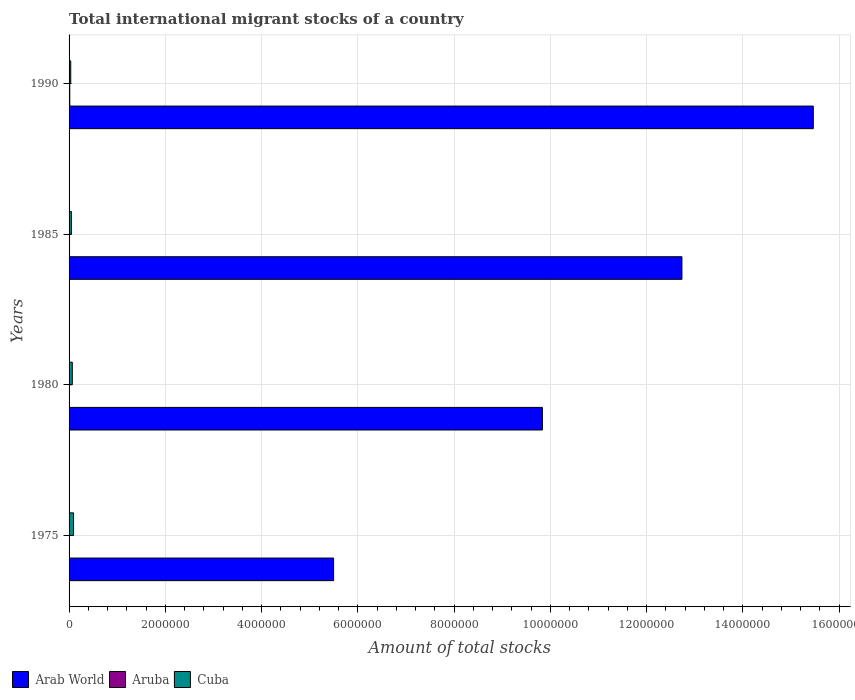How many different coloured bars are there?
Your answer should be compact. 3. How many groups of bars are there?
Your answer should be compact. 4. Are the number of bars on each tick of the Y-axis equal?
Keep it short and to the point. Yes. How many bars are there on the 3rd tick from the top?
Give a very brief answer. 3. How many bars are there on the 3rd tick from the bottom?
Your answer should be compact. 3. What is the amount of total stocks in in Cuba in 1990?
Offer a terse response. 3.46e+04. Across all years, what is the maximum amount of total stocks in in Aruba?
Offer a terse response. 1.44e+04. Across all years, what is the minimum amount of total stocks in in Arab World?
Your response must be concise. 5.50e+06. In which year was the amount of total stocks in in Aruba maximum?
Make the answer very short. 1990. In which year was the amount of total stocks in in Arab World minimum?
Your answer should be compact. 1975. What is the total amount of total stocks in in Arab World in the graph?
Your answer should be very brief. 4.35e+07. What is the difference between the amount of total stocks in in Cuba in 1975 and that in 1990?
Make the answer very short. 5.88e+04. What is the difference between the amount of total stocks in in Cuba in 1990 and the amount of total stocks in in Arab World in 1985?
Offer a terse response. -1.27e+07. What is the average amount of total stocks in in Arab World per year?
Give a very brief answer. 1.09e+07. In the year 1980, what is the difference between the amount of total stocks in in Cuba and amount of total stocks in in Arab World?
Offer a very short reply. -9.77e+06. What is the ratio of the amount of total stocks in in Aruba in 1975 to that in 1985?
Make the answer very short. 0.74. Is the amount of total stocks in in Arab World in 1985 less than that in 1990?
Your answer should be very brief. Yes. What is the difference between the highest and the second highest amount of total stocks in in Cuba?
Ensure brevity in your answer.  2.63e+04. What is the difference between the highest and the lowest amount of total stocks in in Cuba?
Provide a short and direct response. 5.88e+04. Is the sum of the amount of total stocks in in Cuba in 1975 and 1985 greater than the maximum amount of total stocks in in Arab World across all years?
Make the answer very short. No. What does the 3rd bar from the top in 1975 represents?
Keep it short and to the point. Arab World. What does the 1st bar from the bottom in 1990 represents?
Offer a terse response. Arab World. Is it the case that in every year, the sum of the amount of total stocks in in Cuba and amount of total stocks in in Arab World is greater than the amount of total stocks in in Aruba?
Keep it short and to the point. Yes. How many bars are there?
Provide a short and direct response. 12. Are all the bars in the graph horizontal?
Ensure brevity in your answer.  Yes. What is the difference between two consecutive major ticks on the X-axis?
Your response must be concise. 2.00e+06. Are the values on the major ticks of X-axis written in scientific E-notation?
Your answer should be compact. No. Does the graph contain grids?
Your response must be concise. Yes. What is the title of the graph?
Your answer should be very brief. Total international migrant stocks of a country. Does "Central Europe" appear as one of the legend labels in the graph?
Provide a succinct answer. No. What is the label or title of the X-axis?
Your answer should be compact. Amount of total stocks. What is the Amount of total stocks of Arab World in 1975?
Offer a very short reply. 5.50e+06. What is the Amount of total stocks in Aruba in 1975?
Offer a very short reply. 7262. What is the Amount of total stocks of Cuba in 1975?
Give a very brief answer. 9.33e+04. What is the Amount of total stocks of Arab World in 1980?
Offer a very short reply. 9.83e+06. What is the Amount of total stocks of Aruba in 1980?
Offer a very short reply. 7063. What is the Amount of total stocks of Cuba in 1980?
Give a very brief answer. 6.70e+04. What is the Amount of total stocks of Arab World in 1985?
Your response must be concise. 1.27e+07. What is the Amount of total stocks of Aruba in 1985?
Your answer should be compact. 9860. What is the Amount of total stocks of Cuba in 1985?
Keep it short and to the point. 4.81e+04. What is the Amount of total stocks in Arab World in 1990?
Give a very brief answer. 1.55e+07. What is the Amount of total stocks in Aruba in 1990?
Ensure brevity in your answer.  1.44e+04. What is the Amount of total stocks of Cuba in 1990?
Give a very brief answer. 3.46e+04. Across all years, what is the maximum Amount of total stocks of Arab World?
Your answer should be very brief. 1.55e+07. Across all years, what is the maximum Amount of total stocks in Aruba?
Provide a short and direct response. 1.44e+04. Across all years, what is the maximum Amount of total stocks in Cuba?
Offer a very short reply. 9.33e+04. Across all years, what is the minimum Amount of total stocks of Arab World?
Keep it short and to the point. 5.50e+06. Across all years, what is the minimum Amount of total stocks of Aruba?
Ensure brevity in your answer.  7063. Across all years, what is the minimum Amount of total stocks of Cuba?
Your answer should be very brief. 3.46e+04. What is the total Amount of total stocks of Arab World in the graph?
Provide a succinct answer. 4.35e+07. What is the total Amount of total stocks of Aruba in the graph?
Keep it short and to the point. 3.86e+04. What is the total Amount of total stocks in Cuba in the graph?
Provide a short and direct response. 2.43e+05. What is the difference between the Amount of total stocks in Arab World in 1975 and that in 1980?
Your response must be concise. -4.34e+06. What is the difference between the Amount of total stocks in Aruba in 1975 and that in 1980?
Ensure brevity in your answer.  199. What is the difference between the Amount of total stocks of Cuba in 1975 and that in 1980?
Make the answer very short. 2.63e+04. What is the difference between the Amount of total stocks of Arab World in 1975 and that in 1985?
Give a very brief answer. -7.24e+06. What is the difference between the Amount of total stocks in Aruba in 1975 and that in 1985?
Your answer should be very brief. -2598. What is the difference between the Amount of total stocks of Cuba in 1975 and that in 1985?
Your answer should be very brief. 4.52e+04. What is the difference between the Amount of total stocks in Arab World in 1975 and that in 1990?
Give a very brief answer. -9.97e+06. What is the difference between the Amount of total stocks of Aruba in 1975 and that in 1990?
Provide a short and direct response. -7182. What is the difference between the Amount of total stocks in Cuba in 1975 and that in 1990?
Make the answer very short. 5.88e+04. What is the difference between the Amount of total stocks in Arab World in 1980 and that in 1985?
Your answer should be compact. -2.90e+06. What is the difference between the Amount of total stocks of Aruba in 1980 and that in 1985?
Provide a short and direct response. -2797. What is the difference between the Amount of total stocks of Cuba in 1980 and that in 1985?
Your answer should be compact. 1.89e+04. What is the difference between the Amount of total stocks in Arab World in 1980 and that in 1990?
Your answer should be compact. -5.63e+06. What is the difference between the Amount of total stocks of Aruba in 1980 and that in 1990?
Your answer should be very brief. -7381. What is the difference between the Amount of total stocks in Cuba in 1980 and that in 1990?
Give a very brief answer. 3.25e+04. What is the difference between the Amount of total stocks of Arab World in 1985 and that in 1990?
Offer a terse response. -2.73e+06. What is the difference between the Amount of total stocks of Aruba in 1985 and that in 1990?
Your response must be concise. -4584. What is the difference between the Amount of total stocks of Cuba in 1985 and that in 1990?
Give a very brief answer. 1.36e+04. What is the difference between the Amount of total stocks of Arab World in 1975 and the Amount of total stocks of Aruba in 1980?
Provide a succinct answer. 5.49e+06. What is the difference between the Amount of total stocks in Arab World in 1975 and the Amount of total stocks in Cuba in 1980?
Ensure brevity in your answer.  5.43e+06. What is the difference between the Amount of total stocks in Aruba in 1975 and the Amount of total stocks in Cuba in 1980?
Your answer should be very brief. -5.97e+04. What is the difference between the Amount of total stocks of Arab World in 1975 and the Amount of total stocks of Aruba in 1985?
Your response must be concise. 5.49e+06. What is the difference between the Amount of total stocks of Arab World in 1975 and the Amount of total stocks of Cuba in 1985?
Ensure brevity in your answer.  5.45e+06. What is the difference between the Amount of total stocks of Aruba in 1975 and the Amount of total stocks of Cuba in 1985?
Ensure brevity in your answer.  -4.09e+04. What is the difference between the Amount of total stocks in Arab World in 1975 and the Amount of total stocks in Aruba in 1990?
Your response must be concise. 5.48e+06. What is the difference between the Amount of total stocks of Arab World in 1975 and the Amount of total stocks of Cuba in 1990?
Make the answer very short. 5.46e+06. What is the difference between the Amount of total stocks of Aruba in 1975 and the Amount of total stocks of Cuba in 1990?
Keep it short and to the point. -2.73e+04. What is the difference between the Amount of total stocks in Arab World in 1980 and the Amount of total stocks in Aruba in 1985?
Provide a short and direct response. 9.82e+06. What is the difference between the Amount of total stocks of Arab World in 1980 and the Amount of total stocks of Cuba in 1985?
Keep it short and to the point. 9.79e+06. What is the difference between the Amount of total stocks in Aruba in 1980 and the Amount of total stocks in Cuba in 1985?
Keep it short and to the point. -4.11e+04. What is the difference between the Amount of total stocks of Arab World in 1980 and the Amount of total stocks of Aruba in 1990?
Your answer should be very brief. 9.82e+06. What is the difference between the Amount of total stocks in Arab World in 1980 and the Amount of total stocks in Cuba in 1990?
Make the answer very short. 9.80e+06. What is the difference between the Amount of total stocks in Aruba in 1980 and the Amount of total stocks in Cuba in 1990?
Your response must be concise. -2.75e+04. What is the difference between the Amount of total stocks in Arab World in 1985 and the Amount of total stocks in Aruba in 1990?
Keep it short and to the point. 1.27e+07. What is the difference between the Amount of total stocks of Arab World in 1985 and the Amount of total stocks of Cuba in 1990?
Ensure brevity in your answer.  1.27e+07. What is the difference between the Amount of total stocks in Aruba in 1985 and the Amount of total stocks in Cuba in 1990?
Ensure brevity in your answer.  -2.47e+04. What is the average Amount of total stocks of Arab World per year?
Keep it short and to the point. 1.09e+07. What is the average Amount of total stocks of Aruba per year?
Offer a very short reply. 9657.25. What is the average Amount of total stocks in Cuba per year?
Give a very brief answer. 6.08e+04. In the year 1975, what is the difference between the Amount of total stocks of Arab World and Amount of total stocks of Aruba?
Give a very brief answer. 5.49e+06. In the year 1975, what is the difference between the Amount of total stocks of Arab World and Amount of total stocks of Cuba?
Offer a very short reply. 5.40e+06. In the year 1975, what is the difference between the Amount of total stocks in Aruba and Amount of total stocks in Cuba?
Make the answer very short. -8.61e+04. In the year 1980, what is the difference between the Amount of total stocks in Arab World and Amount of total stocks in Aruba?
Your answer should be compact. 9.83e+06. In the year 1980, what is the difference between the Amount of total stocks of Arab World and Amount of total stocks of Cuba?
Provide a short and direct response. 9.77e+06. In the year 1980, what is the difference between the Amount of total stocks of Aruba and Amount of total stocks of Cuba?
Your response must be concise. -5.99e+04. In the year 1985, what is the difference between the Amount of total stocks of Arab World and Amount of total stocks of Aruba?
Your answer should be very brief. 1.27e+07. In the year 1985, what is the difference between the Amount of total stocks of Arab World and Amount of total stocks of Cuba?
Offer a terse response. 1.27e+07. In the year 1985, what is the difference between the Amount of total stocks in Aruba and Amount of total stocks in Cuba?
Offer a terse response. -3.83e+04. In the year 1990, what is the difference between the Amount of total stocks in Arab World and Amount of total stocks in Aruba?
Your answer should be compact. 1.54e+07. In the year 1990, what is the difference between the Amount of total stocks in Arab World and Amount of total stocks in Cuba?
Make the answer very short. 1.54e+07. In the year 1990, what is the difference between the Amount of total stocks of Aruba and Amount of total stocks of Cuba?
Offer a very short reply. -2.01e+04. What is the ratio of the Amount of total stocks of Arab World in 1975 to that in 1980?
Give a very brief answer. 0.56. What is the ratio of the Amount of total stocks of Aruba in 1975 to that in 1980?
Your answer should be compact. 1.03. What is the ratio of the Amount of total stocks of Cuba in 1975 to that in 1980?
Make the answer very short. 1.39. What is the ratio of the Amount of total stocks in Arab World in 1975 to that in 1985?
Make the answer very short. 0.43. What is the ratio of the Amount of total stocks of Aruba in 1975 to that in 1985?
Make the answer very short. 0.74. What is the ratio of the Amount of total stocks in Cuba in 1975 to that in 1985?
Ensure brevity in your answer.  1.94. What is the ratio of the Amount of total stocks of Arab World in 1975 to that in 1990?
Keep it short and to the point. 0.36. What is the ratio of the Amount of total stocks of Aruba in 1975 to that in 1990?
Offer a terse response. 0.5. What is the ratio of the Amount of total stocks of Cuba in 1975 to that in 1990?
Keep it short and to the point. 2.7. What is the ratio of the Amount of total stocks in Arab World in 1980 to that in 1985?
Your answer should be very brief. 0.77. What is the ratio of the Amount of total stocks of Aruba in 1980 to that in 1985?
Make the answer very short. 0.72. What is the ratio of the Amount of total stocks of Cuba in 1980 to that in 1985?
Your answer should be compact. 1.39. What is the ratio of the Amount of total stocks of Arab World in 1980 to that in 1990?
Offer a very short reply. 0.64. What is the ratio of the Amount of total stocks of Aruba in 1980 to that in 1990?
Keep it short and to the point. 0.49. What is the ratio of the Amount of total stocks of Cuba in 1980 to that in 1990?
Offer a terse response. 1.94. What is the ratio of the Amount of total stocks of Arab World in 1985 to that in 1990?
Your answer should be compact. 0.82. What is the ratio of the Amount of total stocks in Aruba in 1985 to that in 1990?
Give a very brief answer. 0.68. What is the ratio of the Amount of total stocks of Cuba in 1985 to that in 1990?
Offer a very short reply. 1.39. What is the difference between the highest and the second highest Amount of total stocks of Arab World?
Give a very brief answer. 2.73e+06. What is the difference between the highest and the second highest Amount of total stocks of Aruba?
Your answer should be compact. 4584. What is the difference between the highest and the second highest Amount of total stocks in Cuba?
Your answer should be compact. 2.63e+04. What is the difference between the highest and the lowest Amount of total stocks of Arab World?
Provide a short and direct response. 9.97e+06. What is the difference between the highest and the lowest Amount of total stocks of Aruba?
Offer a terse response. 7381. What is the difference between the highest and the lowest Amount of total stocks in Cuba?
Ensure brevity in your answer.  5.88e+04. 